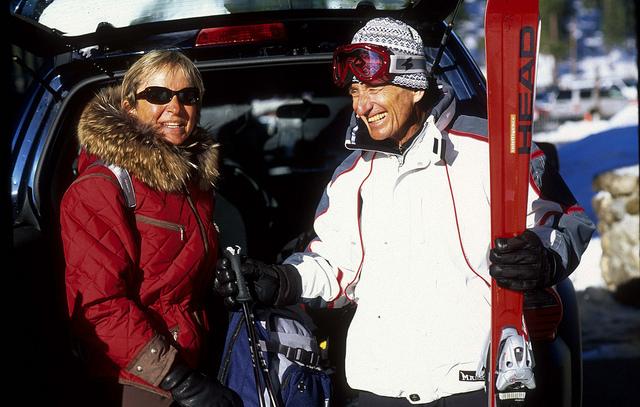What does the man have in his hands?
Write a very short answer. Skis. What does the woman have on her forehead?
Answer briefly. Hair. What is on this person's head?
Keep it brief. Hat. Are the people happy?
Write a very short answer. Yes. Is the woman wearing goggles?
Answer briefly. No. 